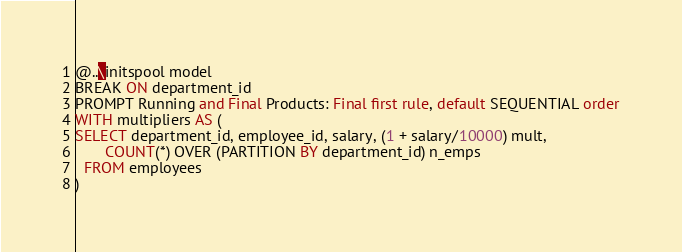<code> <loc_0><loc_0><loc_500><loc_500><_SQL_>@..\initspool model
BREAK ON department_id
PROMPT Running and Final Products: Final first rule, default SEQUENTIAL order
WITH multipliers AS (
SELECT department_id, employee_id, salary, (1 + salary/10000) mult, 
       COUNT(*) OVER (PARTITION BY department_id) n_emps
  FROM employees
)</code> 